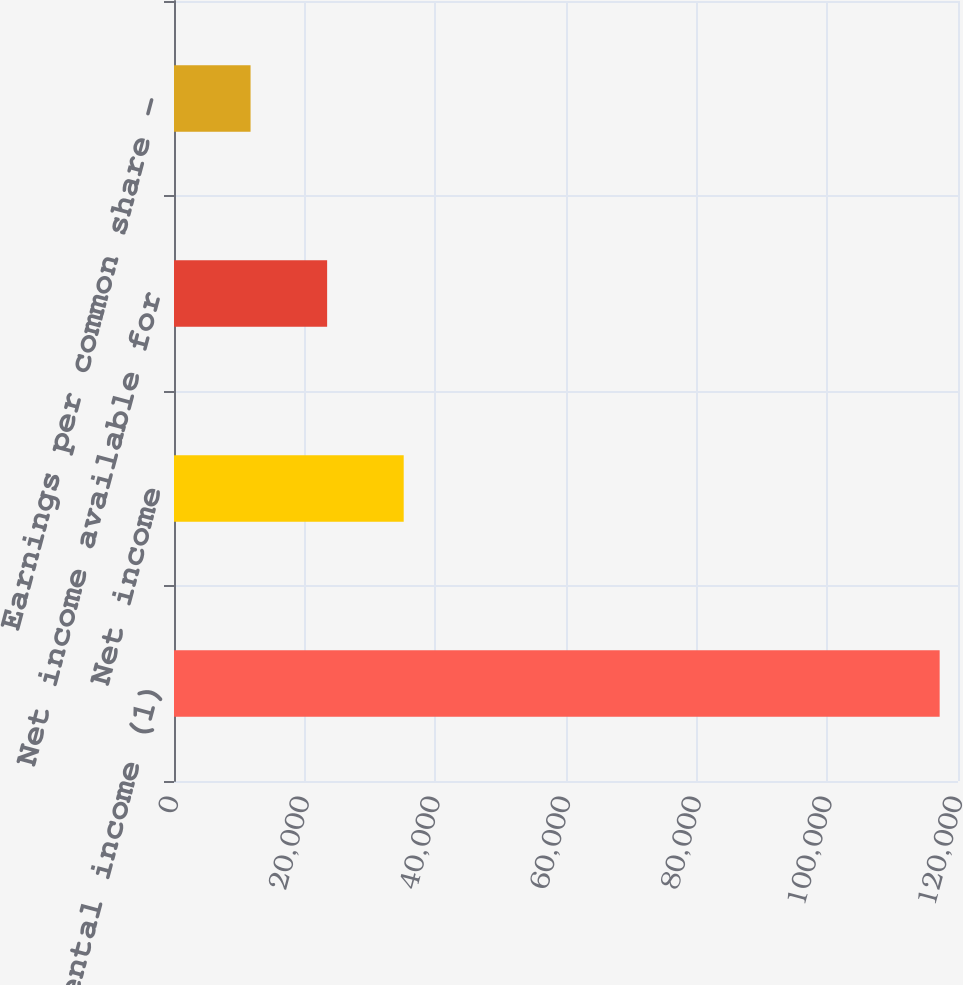Convert chart. <chart><loc_0><loc_0><loc_500><loc_500><bar_chart><fcel>Rental income (1)<fcel>Net income<fcel>Net income available for<fcel>Earnings per common share -<nl><fcel>117193<fcel>35158.1<fcel>23438.9<fcel>11719.6<nl></chart> 